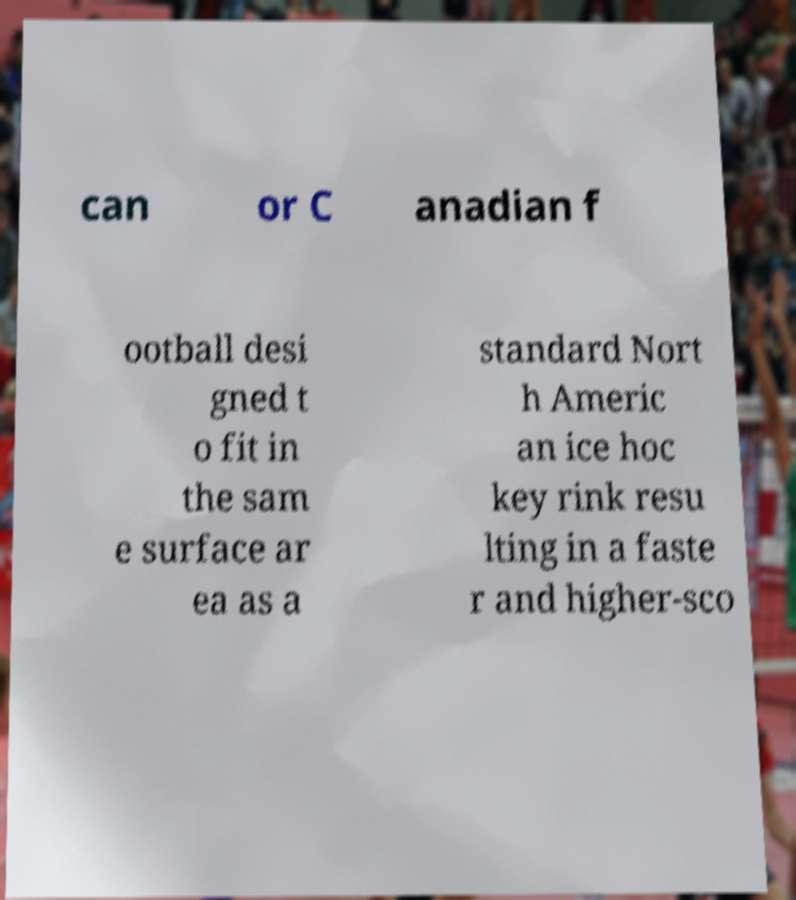Could you assist in decoding the text presented in this image and type it out clearly? can or C anadian f ootball desi gned t o fit in the sam e surface ar ea as a standard Nort h Americ an ice hoc key rink resu lting in a faste r and higher-sco 